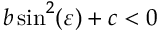<formula> <loc_0><loc_0><loc_500><loc_500>b \sin ^ { 2 } ( \varepsilon ) + c < 0</formula> 